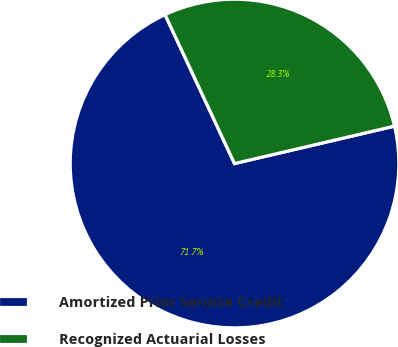Convert chart. <chart><loc_0><loc_0><loc_500><loc_500><pie_chart><fcel>Amortized Prior Service Credit<fcel>Recognized Actuarial Losses<nl><fcel>71.71%<fcel>28.29%<nl></chart> 